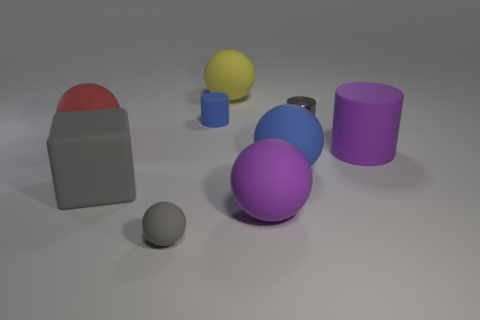Is there anything else that has the same material as the gray cylinder?
Offer a terse response. No. Are there an equal number of yellow rubber things right of the purple ball and small purple spheres?
Provide a succinct answer. Yes. How many other objects are the same color as the small matte cylinder?
Your answer should be compact. 1. There is a ball that is both to the left of the big yellow object and in front of the big gray thing; what is its color?
Your answer should be very brief. Gray. How big is the purple matte object that is to the right of the small gray object that is on the right side of the large sphere right of the big purple sphere?
Your answer should be very brief. Large. How many things are either rubber things left of the big yellow ball or large objects behind the big red object?
Make the answer very short. 5. What is the shape of the yellow matte object?
Provide a short and direct response. Sphere. How many other things are there of the same material as the block?
Your answer should be very brief. 7. The yellow object that is the same shape as the tiny gray matte thing is what size?
Your answer should be very brief. Large. The tiny gray thing in front of the tiny gray shiny cylinder that is to the right of the big purple thing in front of the large gray matte object is made of what material?
Your answer should be compact. Rubber. 